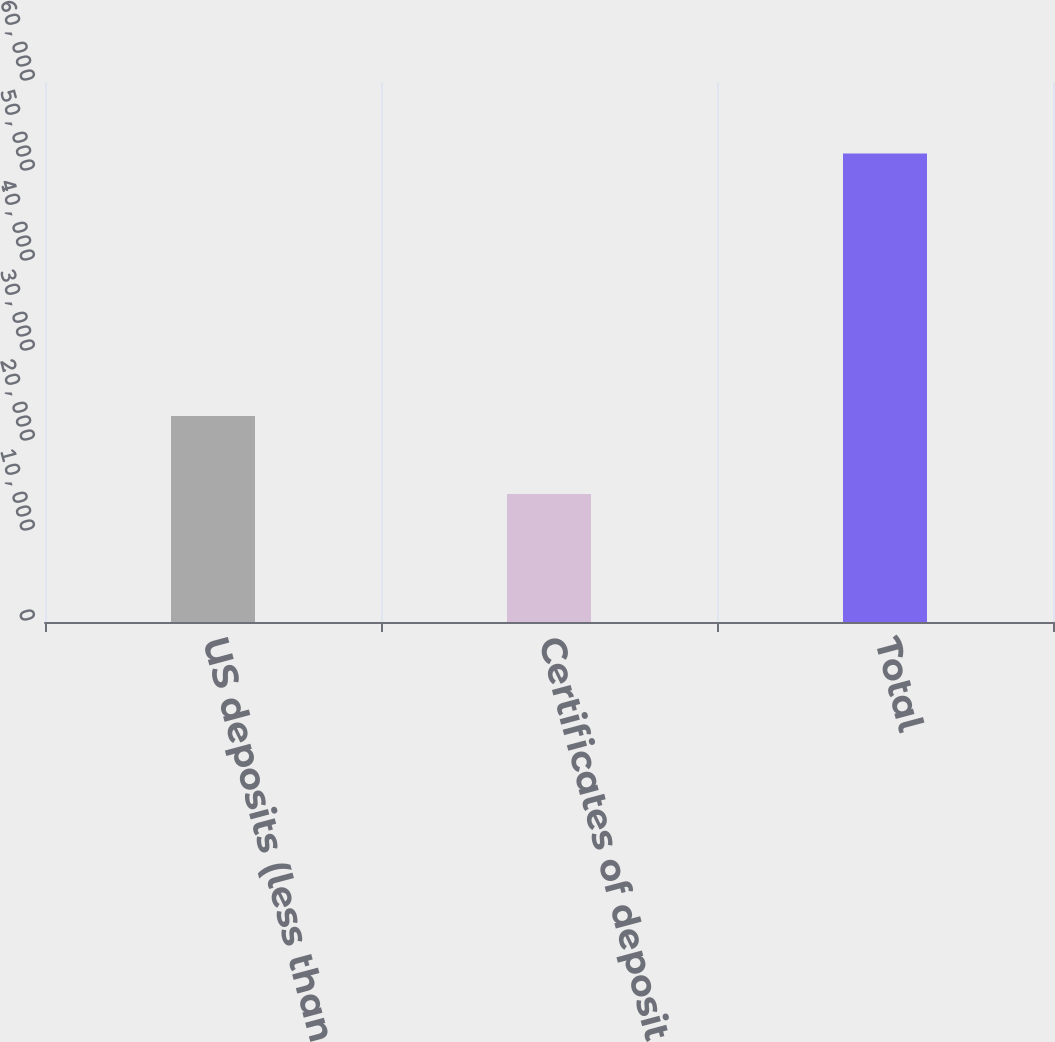Convert chart. <chart><loc_0><loc_0><loc_500><loc_500><bar_chart><fcel>US deposits (less than 100000)<fcel>Certificates of deposit<fcel>Total<nl><fcel>22899<fcel>14222<fcel>52055<nl></chart> 